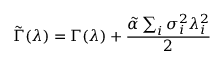<formula> <loc_0><loc_0><loc_500><loc_500>\tilde { \Gamma } ( \lambda ) = \Gamma ( \lambda ) + \frac { \tilde { \alpha } \sum _ { i } \sigma _ { i } ^ { 2 } \lambda _ { i } ^ { 2 } } { 2 }</formula> 